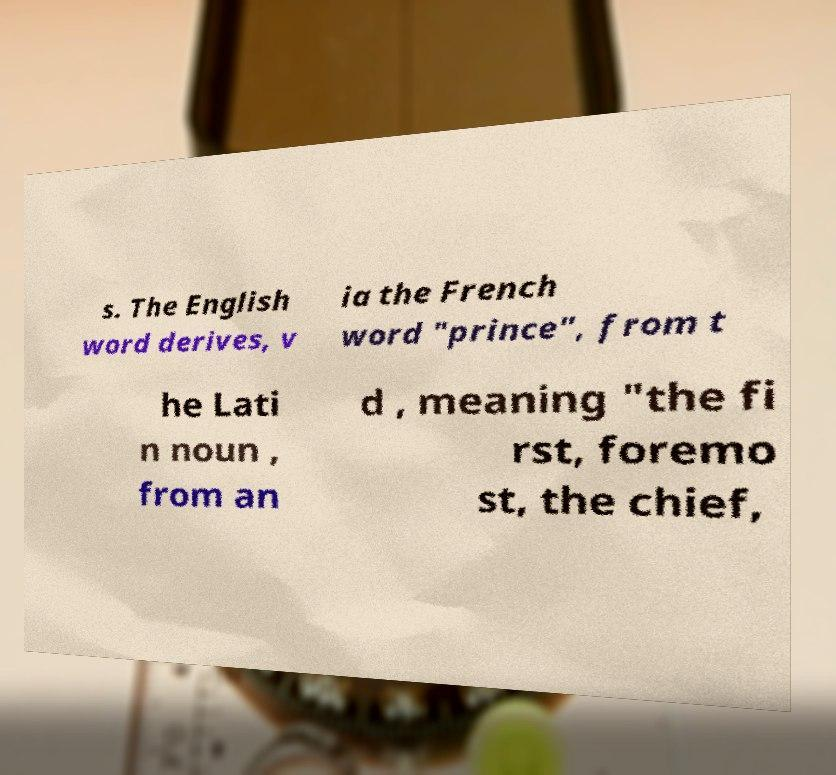Could you extract and type out the text from this image? s. The English word derives, v ia the French word "prince", from t he Lati n noun , from an d , meaning "the fi rst, foremo st, the chief, 